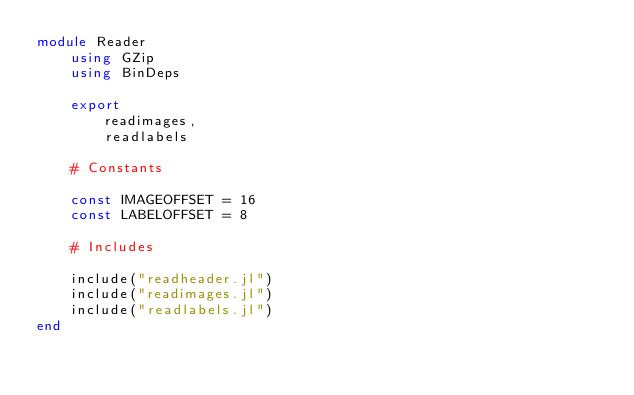Convert code to text. <code><loc_0><loc_0><loc_500><loc_500><_Julia_>module Reader
    using GZip
    using BinDeps

    export
        readimages,
        readlabels

    # Constants

    const IMAGEOFFSET = 16
    const LABELOFFSET = 8

    # Includes

    include("readheader.jl")
    include("readimages.jl")
    include("readlabels.jl")
end
</code> 